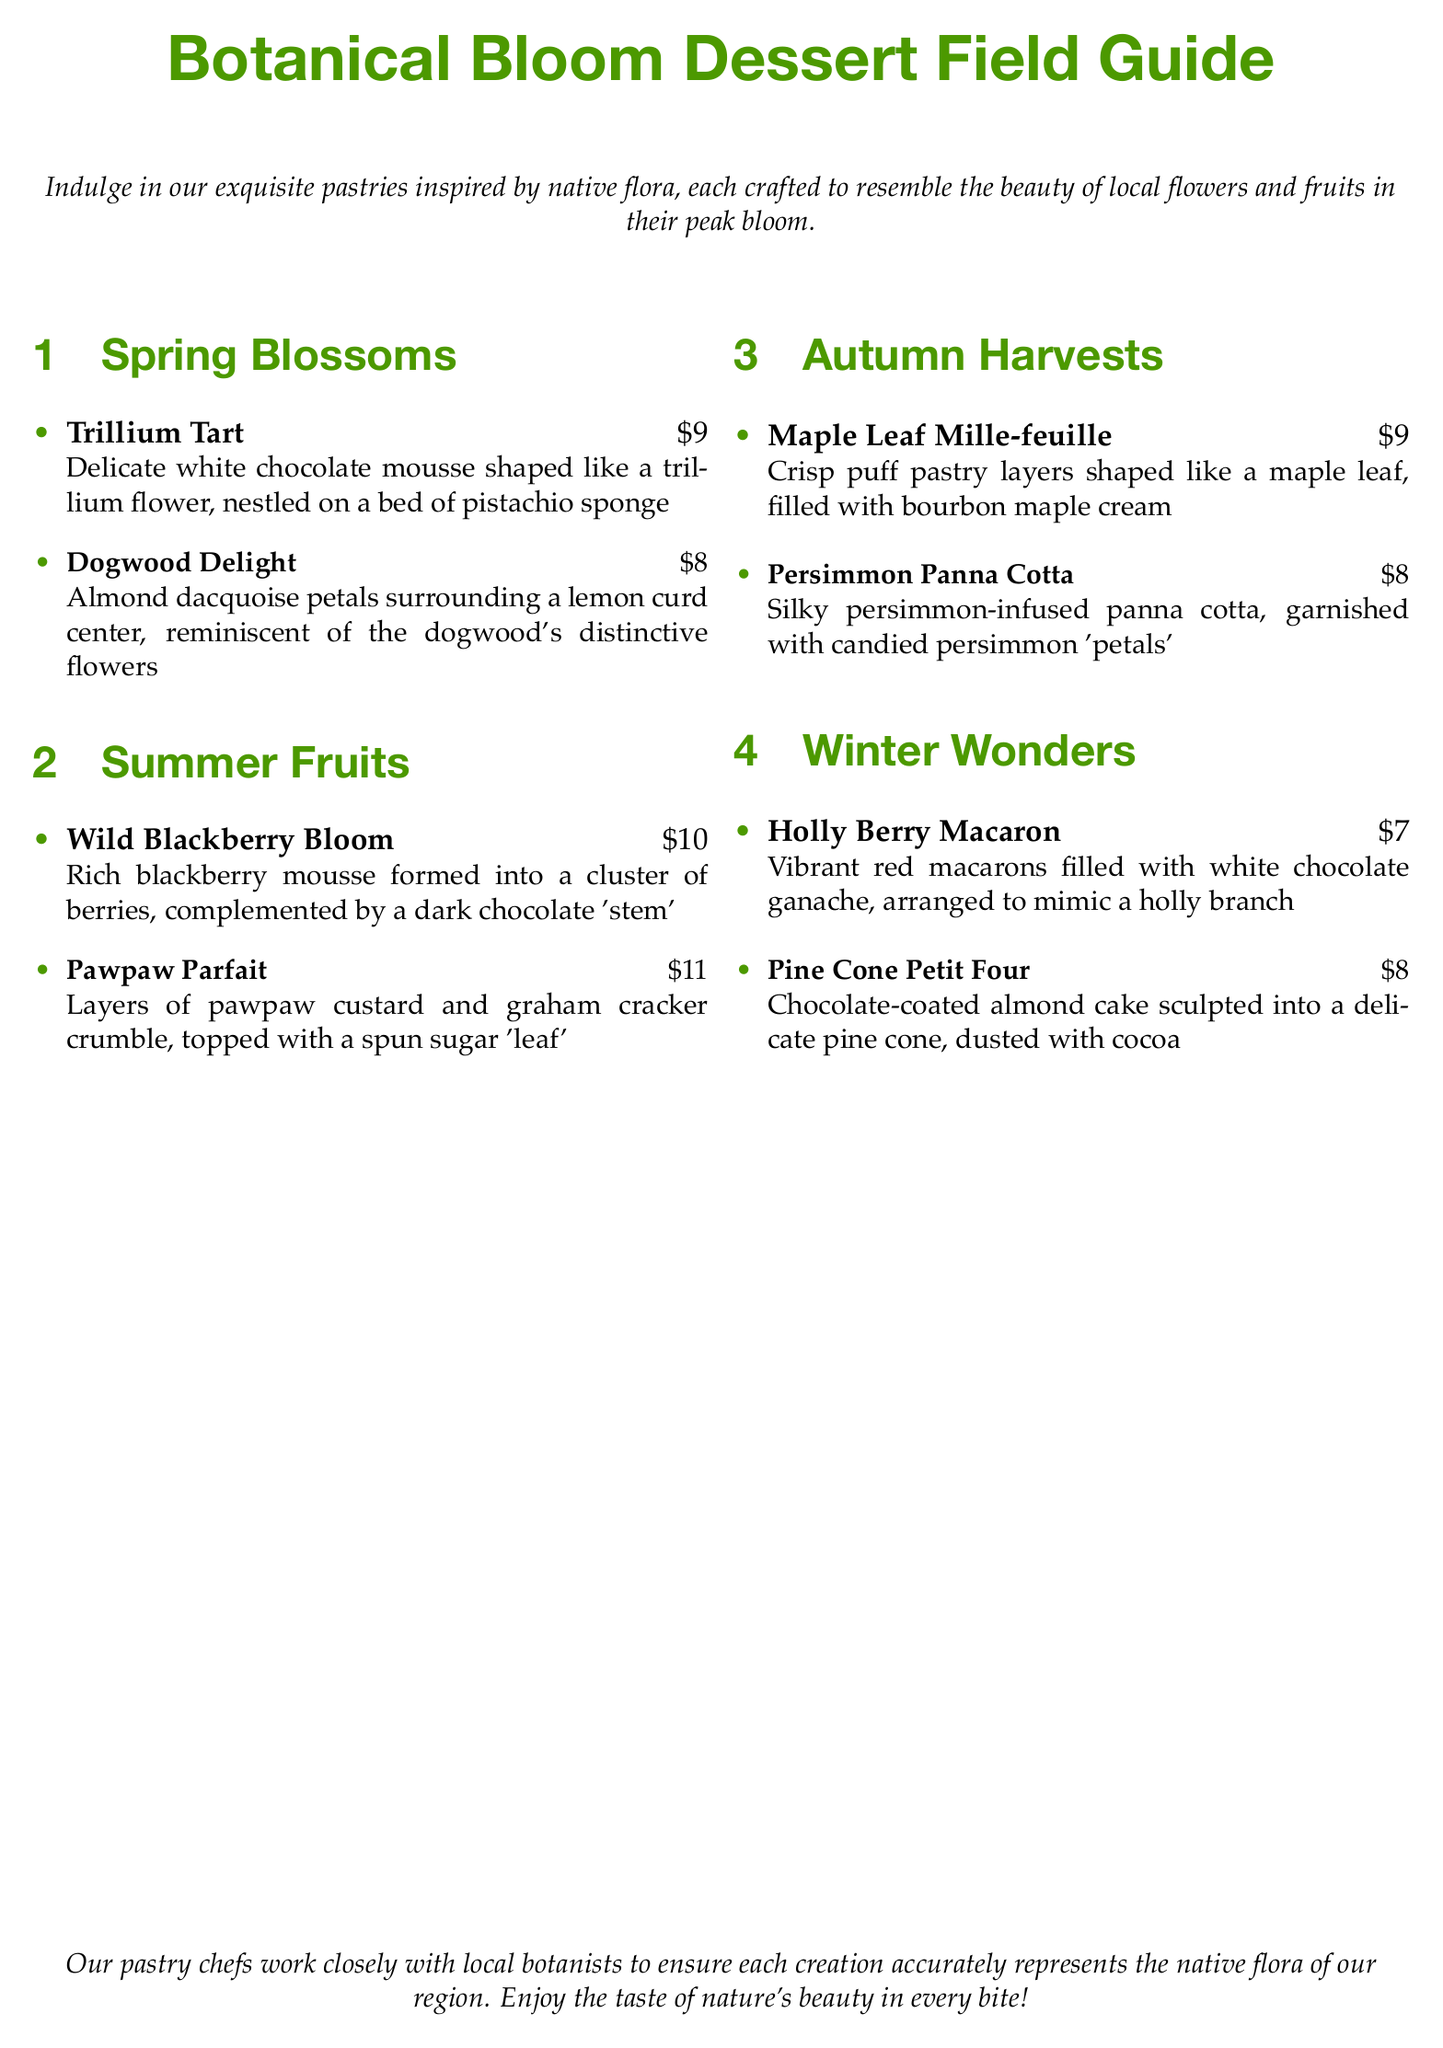What dessert is shaped like a trillium flower? The dessert that is shaped like a trillium flower is called the Trillium Tart.
Answer: Trillium Tart How much does the Dogwood Delight cost? The cost of the Dogwood Delight is listed in the document.
Answer: $8 What type of mousse is featured in the Wild Blackberry Bloom? The Wild Blackberry Bloom features blackberry mousse.
Answer: blackberry mousse Which dessert includes graham cracker crumble? The dessert that includes graham cracker crumble is the Pawpaw Parfait.
Answer: Pawpaw Parfait How many desserts are listed under Spring Blossoms? The number of desserts listed under Spring Blossoms can be counted directly from the section.
Answer: 2 Which dessert is specifically inspired by a native fruit? The dessert inspired by a native fruit is the Pawpaw Parfait.
Answer: Pawpaw Parfait What is the main filling of the Holly Berry Macaron? The main filling of the Holly Berry Macaron is white chocolate ganache.
Answer: white chocolate ganache Which season features a dessert shaped like a maple leaf? The season that features a dessert shaped like a maple leaf is Autumn.
Answer: Autumn What is the unique garnish on the Persimmon Panna Cotta? The unique garnish on the Persimmon Panna Cotta is candied persimmon 'petals'.
Answer: candied persimmon 'petals' 